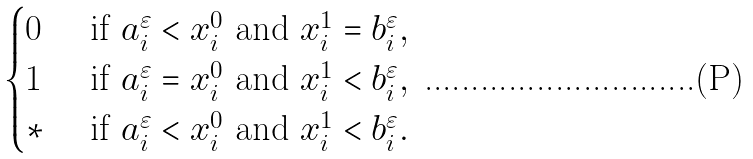Convert formula to latex. <formula><loc_0><loc_0><loc_500><loc_500>\begin{cases} 0 & \text { if } a _ { i } ^ { \varepsilon } < x _ { i } ^ { 0 } \text { and } x _ { i } ^ { 1 } = b _ { i } ^ { \varepsilon } , \\ 1 & \text { if } a _ { i } ^ { \varepsilon } = x _ { i } ^ { 0 } \text { and } x _ { i } ^ { 1 } < b _ { i } ^ { \varepsilon } , \\ \ast & \text { if } a _ { i } ^ { \varepsilon } < x _ { i } ^ { 0 } \text { and } x _ { i } ^ { 1 } < b _ { i } ^ { \varepsilon } . \end{cases}</formula> 